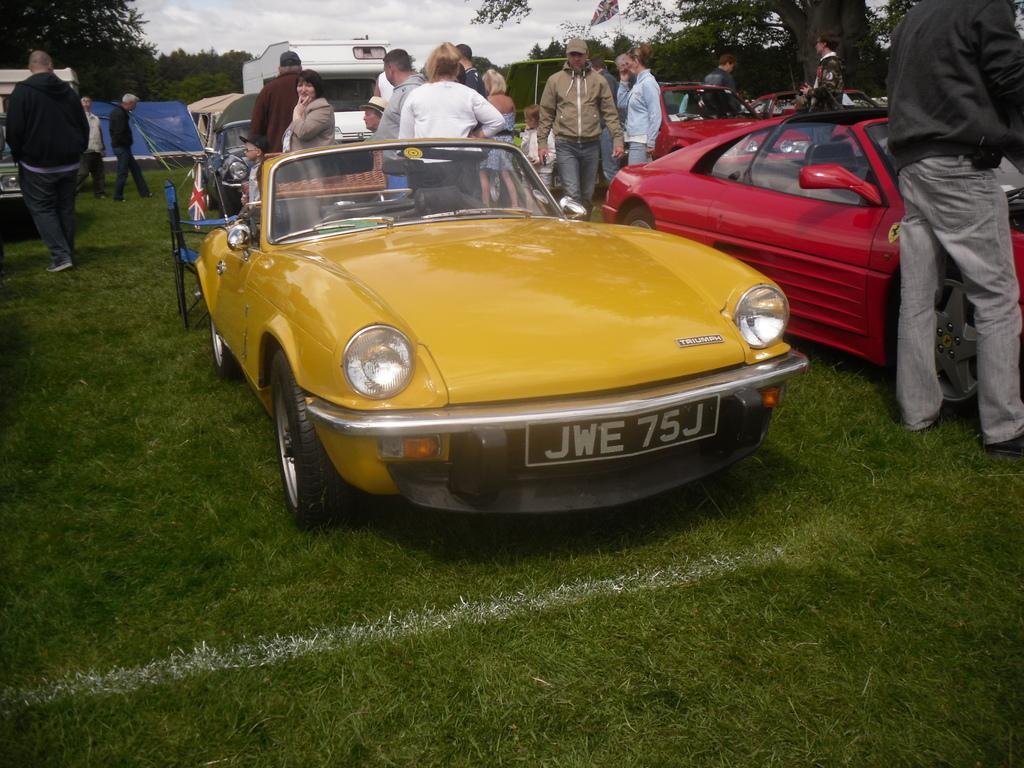What type of surface is visible at the front of the image? There is grass on the ground in the front of the image. What can be seen in the center of the image? There are vehicles and persons standing in the center of the image. What is visible in the background of the image? There are trees and a cloudy sky in the background of the image. What type of appliance is playing music in the image? There is no appliance playing music in the image. Is there a house visible in the image? The provided facts do not mention a house, so it cannot be confirmed or denied. 